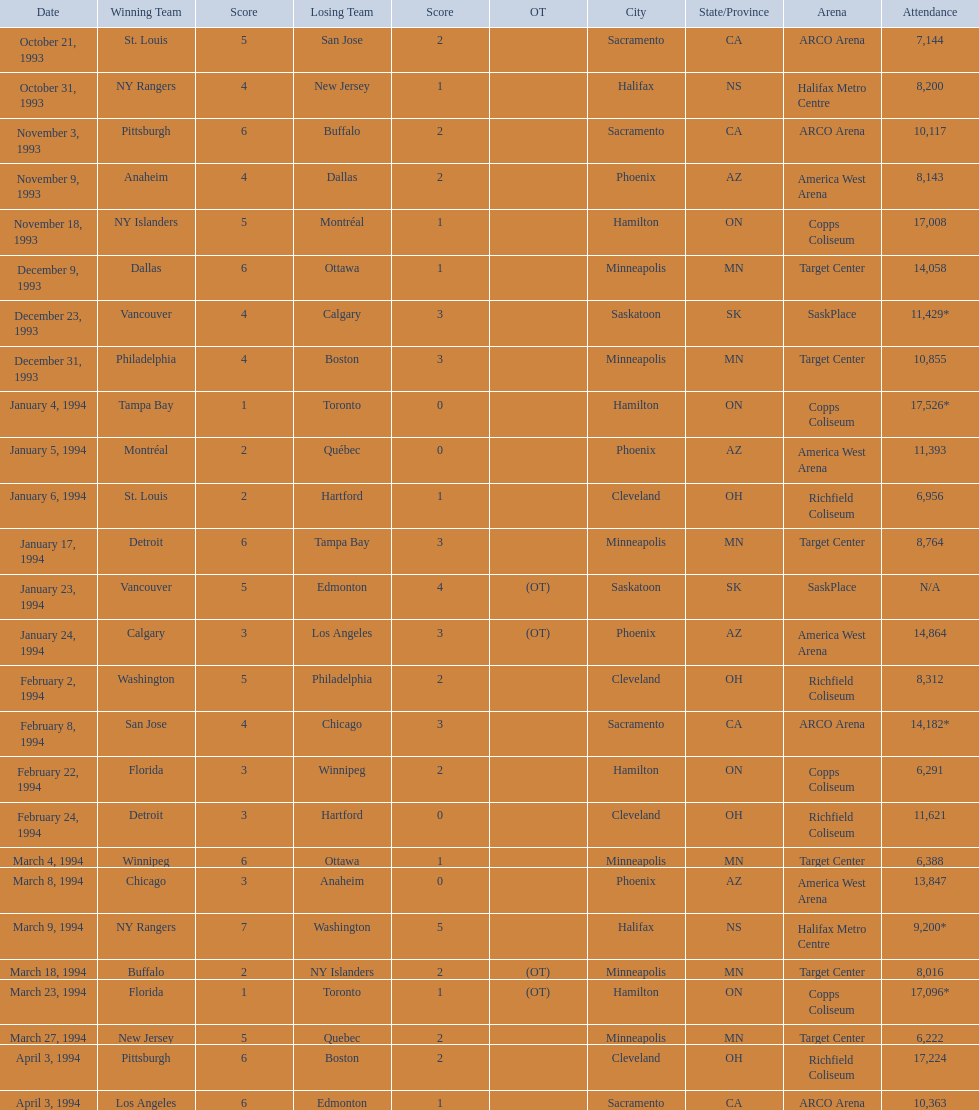On what days did all the games occur? October 21, 1993, October 31, 1993, November 3, 1993, November 9, 1993, November 18, 1993, December 9, 1993, December 23, 1993, December 31, 1993, January 4, 1994, January 5, 1994, January 6, 1994, January 17, 1994, January 23, 1994, January 24, 1994, February 2, 1994, February 8, 1994, February 22, 1994, February 24, 1994, March 4, 1994, March 8, 1994, March 9, 1994, March 18, 1994, March 23, 1994, March 27, 1994, April 3, 1994, April 3, 1994. What were the audience numbers? 7,144, 8,200, 10,117, 8,143, 17,008, 14,058, 11,429*, 10,855, 17,526*, 11,393, 6,956, 8,764, N/A, 14,864, 8,312, 14,182*, 6,291, 11,621, 6,388, 13,847, 9,200*, 8,016, 17,096*, 6,222, 17,224, 10,363. And between december 23, 1993 and january 24, 1994, which match had the greatest attendance? January 4, 1994. 